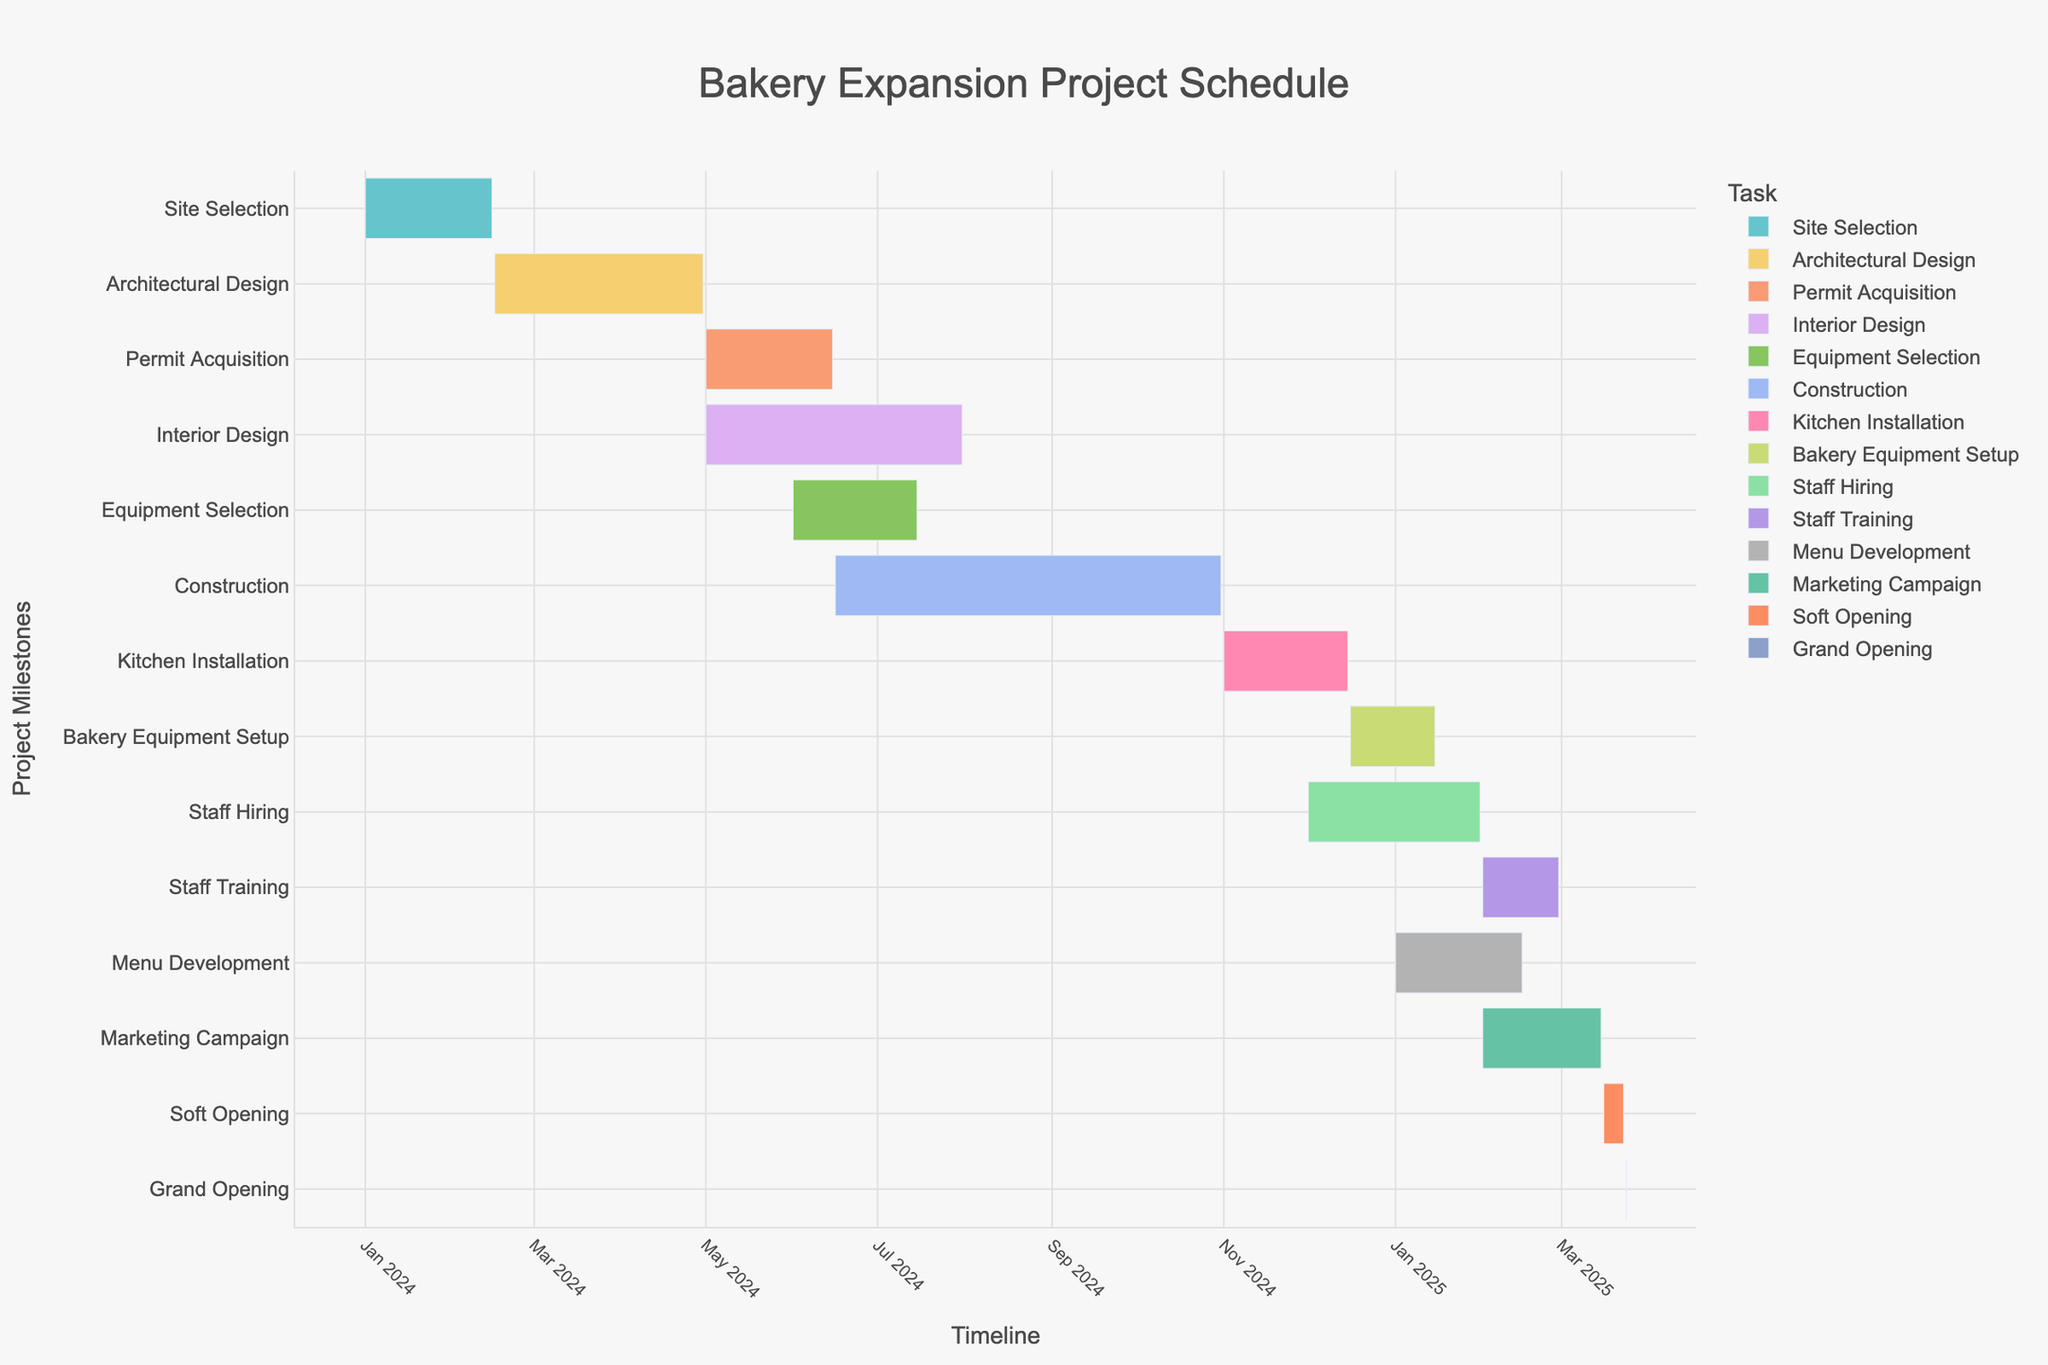What's the title of the Gantt chart? The title can be found at the top of the chart.
Answer: Bakery Expansion Project Schedule What is the time span for the "Construction" task? Locate the “Construction” task on the y-axis, then see the start and end dates along the x-axis. The start date is June 16, 2024, and the end date is October 31, 2024.
Answer: June 16, 2024, to October 31, 2024 Which task comes directly after "Architectural Design"? Find “Architectural Design” on the y-axis and look at the task immediately below it. The next task is “Permit Acquisition.”
Answer: Permit Acquisition How long is the "Staff Training" task in comparison to the "Marketing Campaign" task? Find both “Staff Training” and “Marketing Campaign” on the y-axis and check their durations on the x-axis. “Staff Training” lasts from February 1, 2025, to February 28, 2025, and “Marketing Campaign” lasts from February 1, 2025, to March 15, 2025. Staff Training is shorter.
Answer: Staff Training is shorter Which tasks overlap with the "Interior Design" task? Find "Interior Design" on the y-axis and see its start and end dates on the x-axis (May 1, 2024, to July 31, 2024). Then, check other tasks whose timelines intersect with these dates. Overlapping tasks are “Permit Acquisition” and “Equipment Selection.”
Answer: Permit Acquisition, Equipment Selection What is the total duration of the "Kitchen Installation" and "Bakery Equipment Setup" tasks combined? Find the durations for both tasks. “Kitchen Installation” (November 1, 2024, to December 15, 2024) is 45 days long, and “Bakery Equipment Setup” (December 16, 2024, to January 15, 2025) is 31 days long. The combined duration is 45 + 31 days.
Answer: 76 days When does the "Grand Opening" take place? The "Grand Opening" task can be located on the y-axis, and its corresponding date on the x-axis is shown.
Answer: March 24, 2025 Which task has the longest duration? Look at each task's timeline on the x-axis to identify the one with the longest span. The "Construction" task lasts the longest, from June 16, 2024, to October 31, 2024.
Answer: Construction Are there any tasks starting in January 2025? Scan along the x-axis to January 2025 and see which tasks' start dates fall in that month. Both "Menu Development" and "Bakery Equipment Setup" start in January 2025.
Answer: Menu Development, Bakery Equipment Setup 